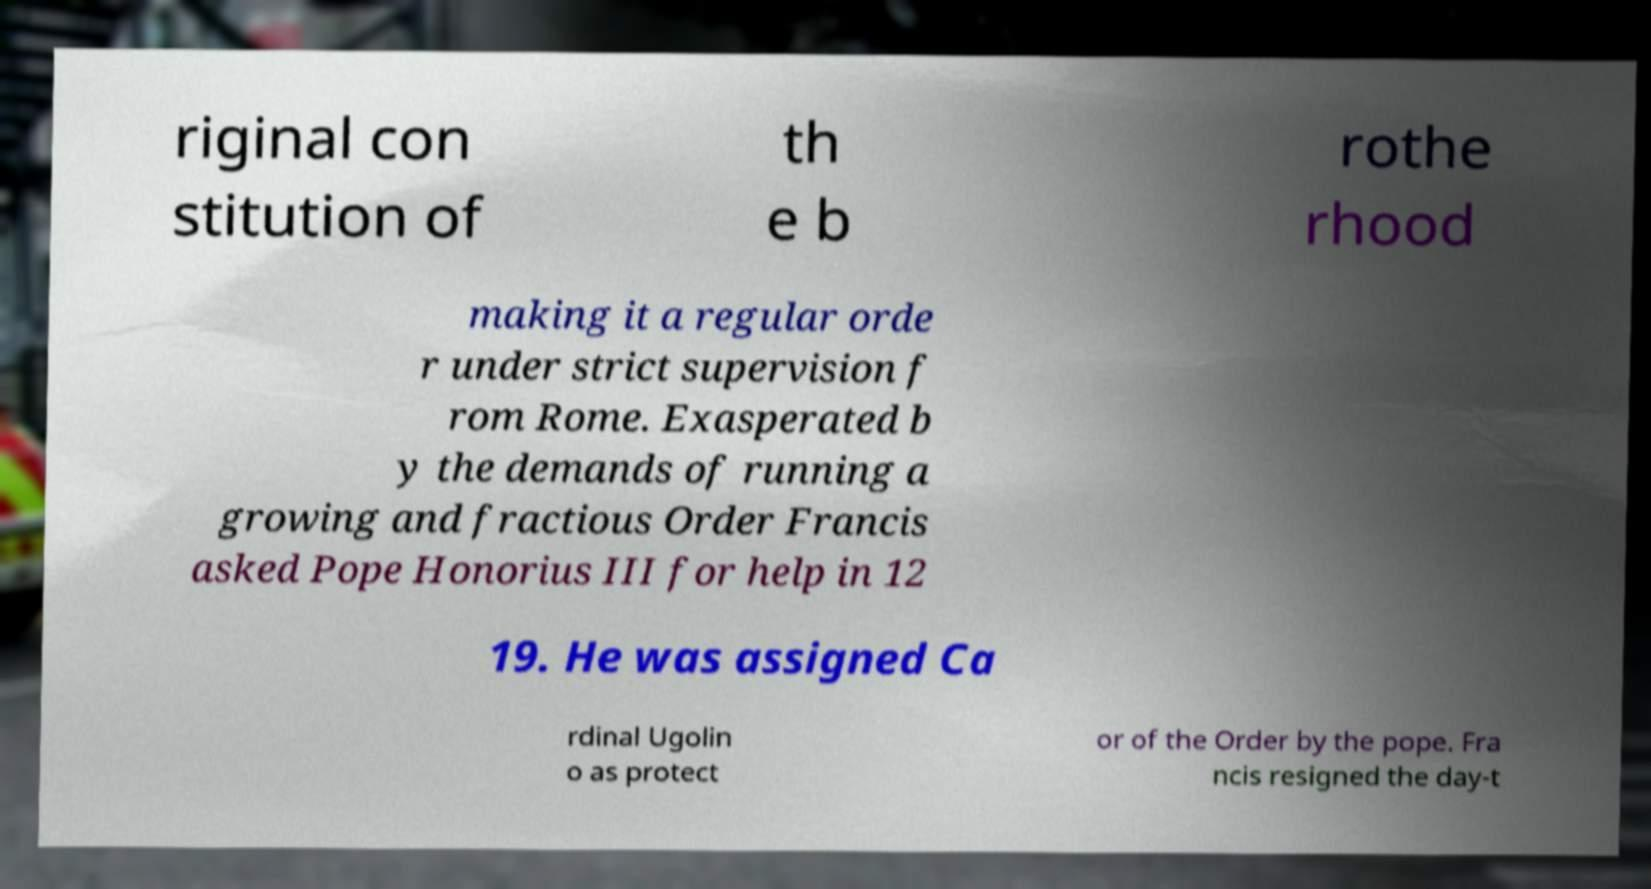Can you accurately transcribe the text from the provided image for me? riginal con stitution of th e b rothe rhood making it a regular orde r under strict supervision f rom Rome. Exasperated b y the demands of running a growing and fractious Order Francis asked Pope Honorius III for help in 12 19. He was assigned Ca rdinal Ugolin o as protect or of the Order by the pope. Fra ncis resigned the day-t 